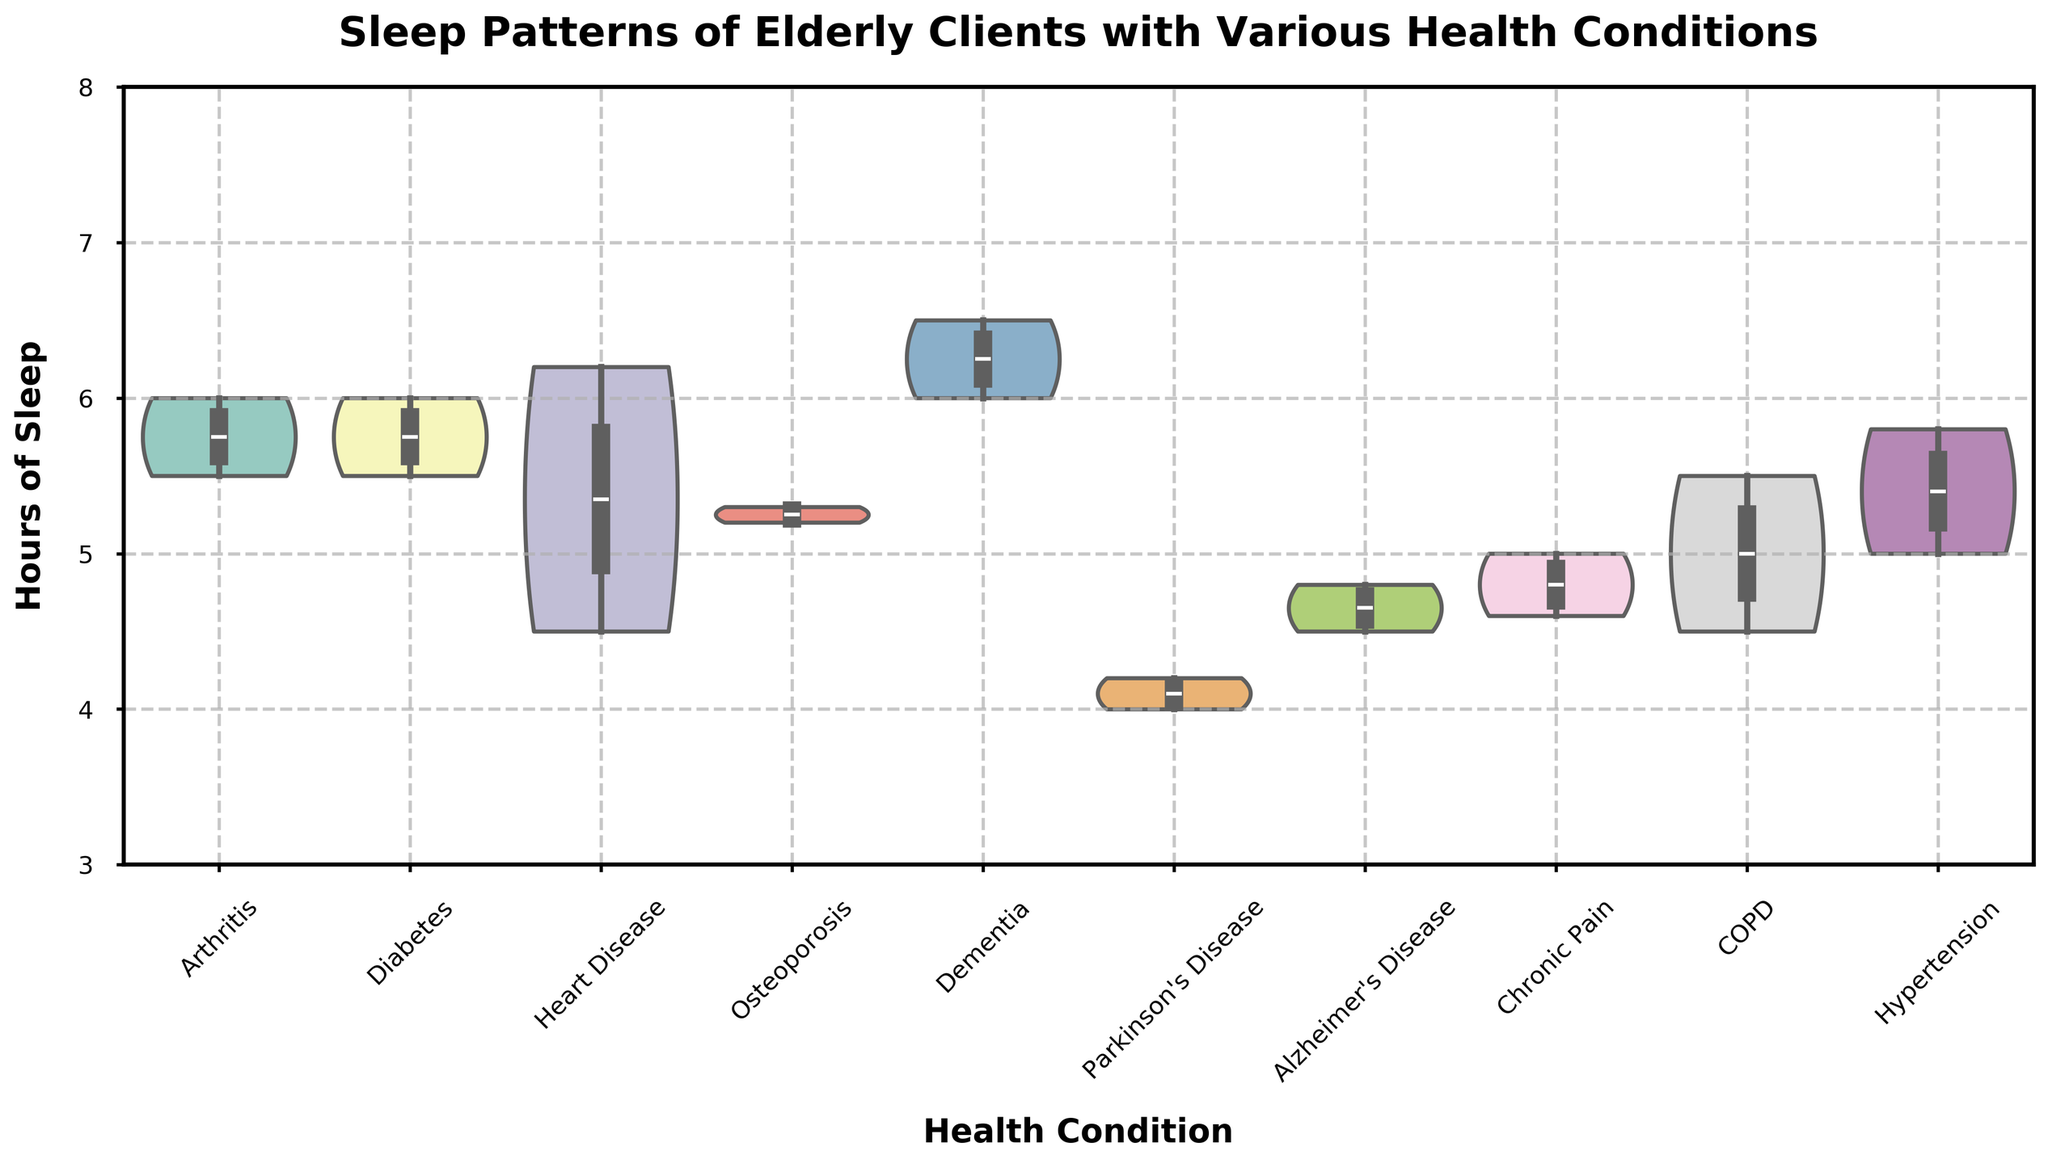What is the title of the violin chart? The title of the chart is typically found at the top and describes what the chart represents. In this case, it is 'Sleep Patterns of Elderly Clients with Various Health Conditions'.
Answer: Sleep Patterns of Elderly Clients with Various Health Conditions How many hours of sleep are displayed on the y-axis? The y-axis shows the range of hours of sleep. By looking at the axis, we can see it ranges from 3 to 8 hours.
Answer: 3 to 8 Which health condition has the widest spread of hours of sleep? By comparing the width of each violin plot, we see that Parkinson's Disease has a more expanded shape, indicating a wider spread of sleep hours.
Answer: Parkinson's Disease What is the median number of hours of sleep for clients with Dementia? The median can be found as the white dot within the box plot inside the violin. For Dementia, the median value is around 6 hours.
Answer: 6.0 Which health condition is associated with the highest median hours of sleep? By inspecting the positions of the white dots (medians) across all conditions, we can see that Dementia and Heart Disease have the same highest median value of 6.0 hours.
Answer: Dementia and Heart Disease What is the shape of the distribution for clients with Arthritis? The shape shows a wider top and narrower bottom, indicating more density around higher hours of sleep (around 6 hours) and less around lower hours.
Answer: Wider top, narrower bottom Which health condition clients have the lowest median hours of sleep? Observing the white dots, Parkinson's Disease has the lowest median sleep hours, situated around 4.1-4.2 hours.
Answer: Parkinson's Disease How do the sleep patterns of clients with Alzheimer's Disease compare to those with Osteoporosis? Alzheimer's Disease has a lower, broader distribution mainly centered below 5 hours, while Osteoporosis has a narrower and higher median around 5.2-5.3 hours.
Answer: Alzheimer's has a broader, lower distribution; Osteoporosis is narrower and higher Is there any health condition with a bimodal distribution? A bimodal distribution shows two peaks within the violin plot. The data does not clearly indicate any bimodal distributions, they are all more unimodal.
Answer: No Which health conditions display the least variability in sleep hours? Variability can be deduced by the narrowness of the violin plot. Both Diabetes and Hypertension display more narrow plots, indicating less variability.
Answer: Diabetes and Hypertension 